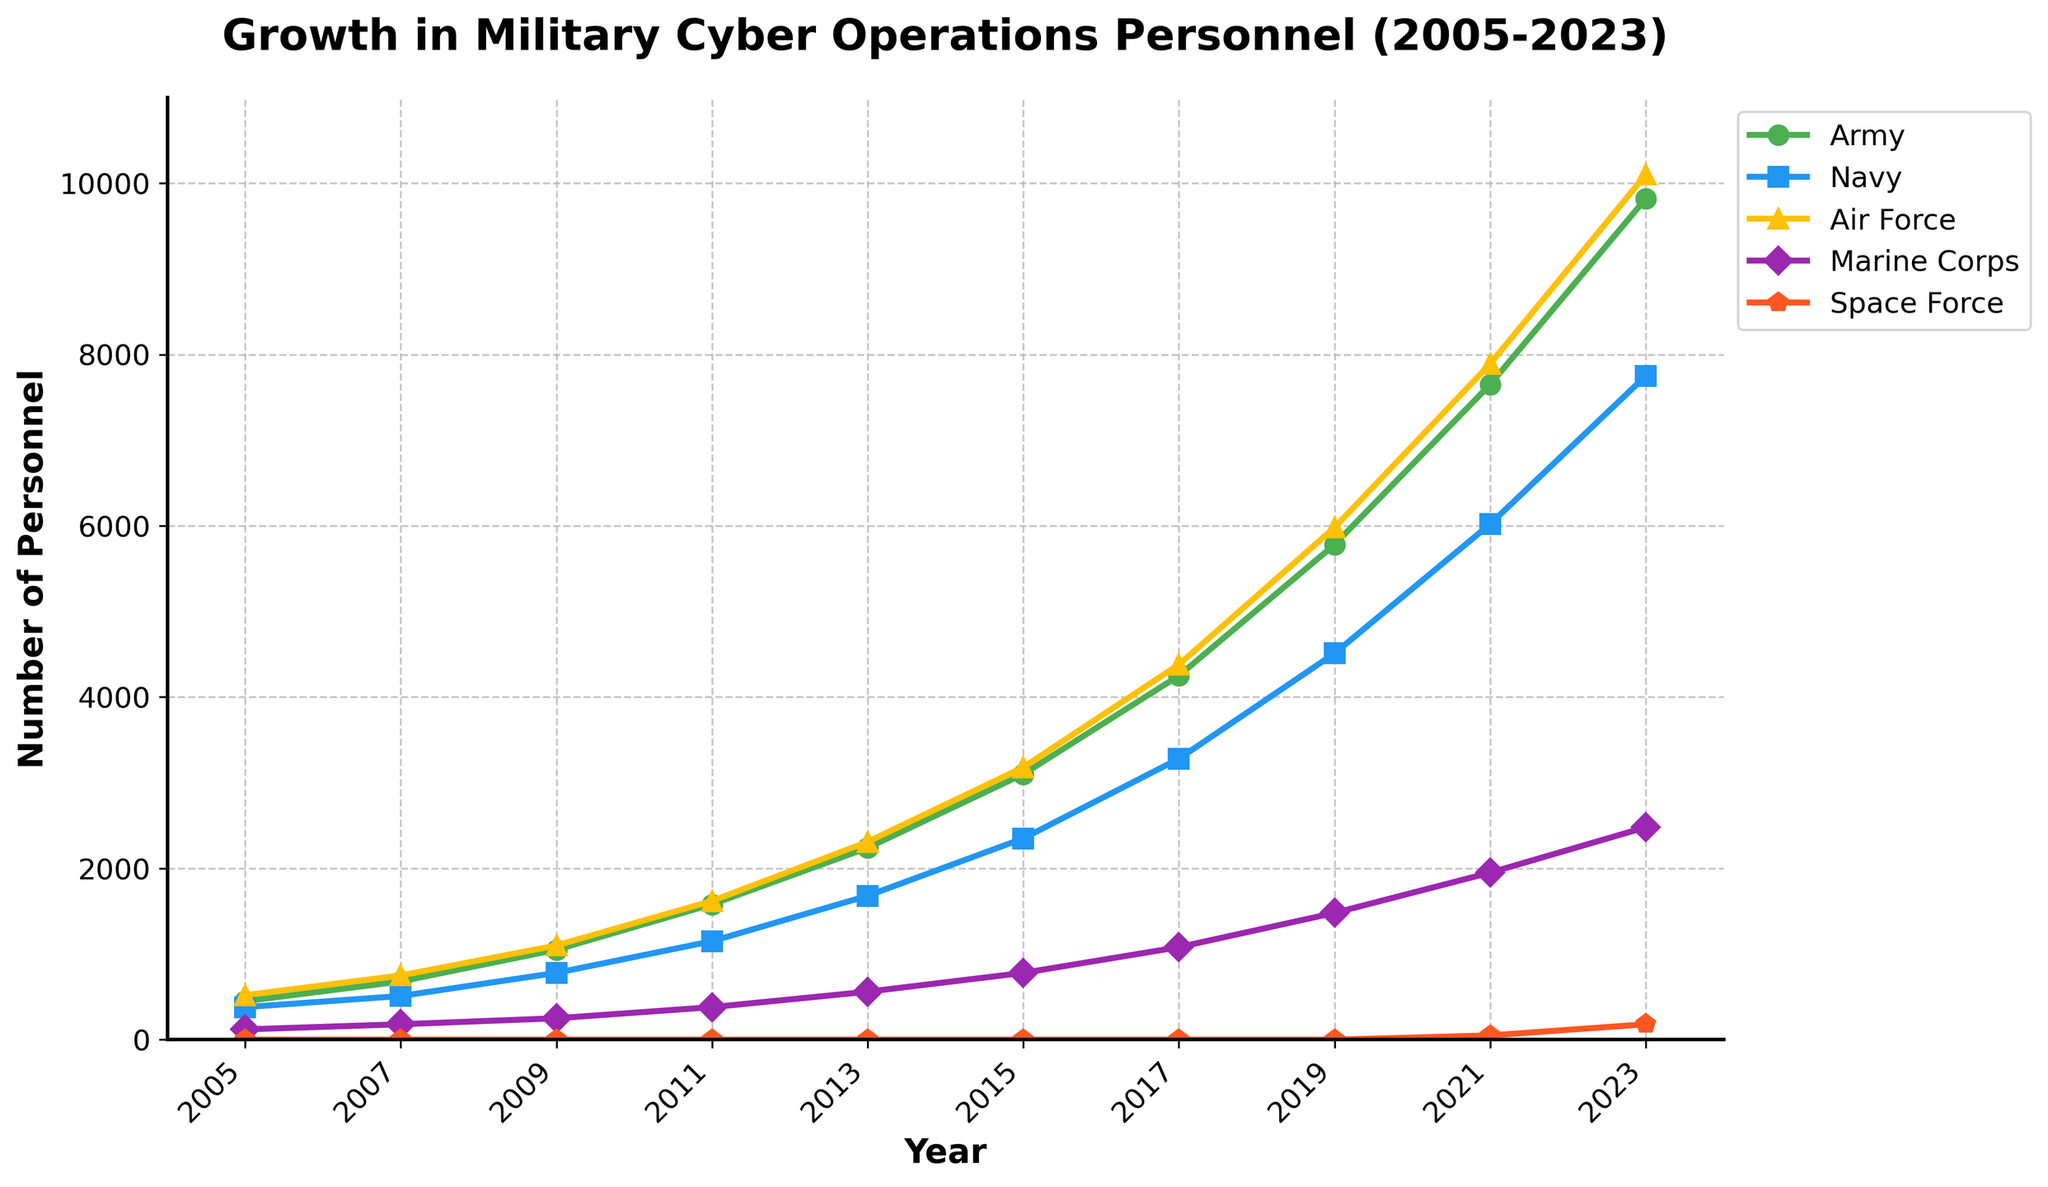What year had the largest increase in the number of Army personnel specialized in cyber operations? To determine the year with the largest increase, calculate the differences between consecutive years. The largest increase for the Army personnel occurs between 2017 and 2019: (5780 - 4250) = 1530.
Answer: 2017 to 2019 Which branch had the smallest number of specialized cyber operations personnel in 2023? By examining the line chart and visually comparing the end points for each branch in 2023, the Space Force has the smallest number of personnel with 180.
Answer: Space Force In 2021, how many more Air Force personnel were there in cyber operations compared to the Navy? Calculate the difference between Air Force and Navy in 2021: (7890 - 6020) = 1870.
Answer: 1870 What is the average number of Navy personnel specialized in cyber operations from 2005 to 2023? Sum the navy personnel counts and divide by the number of years: (380 + 510 + 780 + 1150 + 1680 + 2350 + 3280 + 4510 + 6020 + 7750) / 10 = 3821.
Answer: 3821 Which branch saw the first notable growth after 2019 in specialized cyber operations personnel? Look at the chart from 2019 onward; the Space Force first appears and shows growth from 2021.
Answer: Space Force By how much did the Marine Corps personnel in cyber operations increase from 2007 to 2015? Calculate the difference: (780 - 180) = 600.
Answer: 600 In which year did the Marine Corps surpass 1000 personnel in cyber operations? Observe the Marine Corps line on the chart and find the year it crosses 1000, which is 2017.
Answer: 2017 Which branch had a larger increase in specialized cyber operations personnel between 2009 and 2013, Army or Air Force? Calculate the increase for both: Army (2240 - 1050) = 1190, Air Force (2310 - 1100) = 1210. The Air Force had the larger increase.
Answer: Air Force What is the total number of cyber operations personnel across all branches in 2013? Sum the personnel numbers in 2013: 2240 + 1680 + 2310 + 560 + 0 = 6790.
Answer: 6790 How did the number of Army and Navy personnel in cyber operations compare in 2015? Compare the values in the chart for 2015: Army - 3100, Navy - 2350; the Army has more personnel by (3100 - 2350) = 750.
Answer: Army, 750 more 